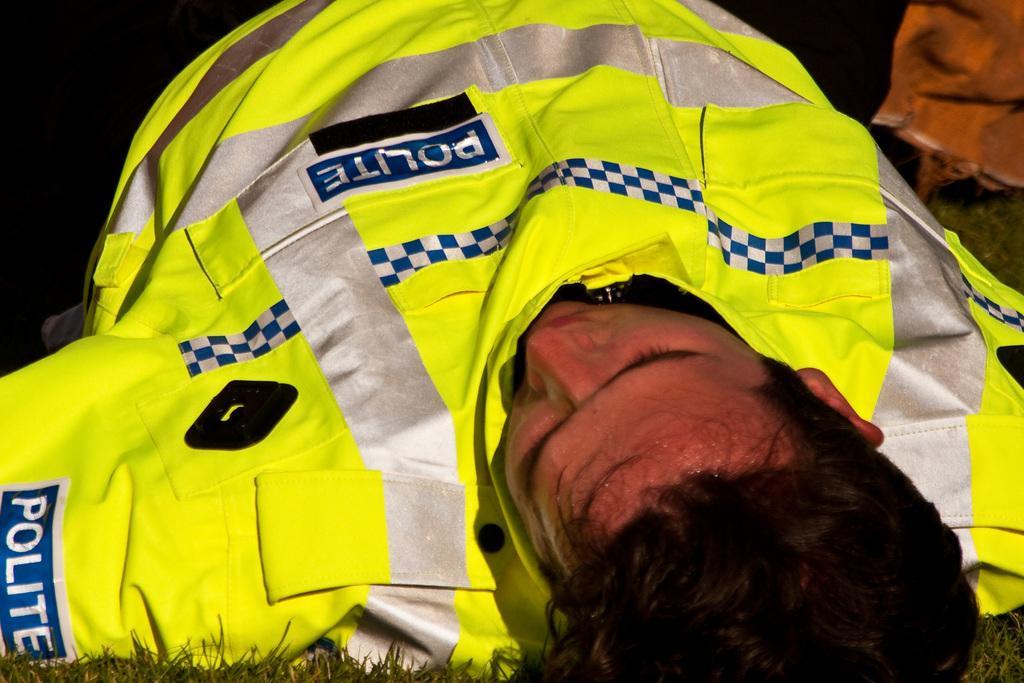In one or two sentences, can you explain what this image depicts? This image is taken outdoors. At the bottom of the image there is a ground with grass on it. In the middle of the image a man is sleeping on the ground. 